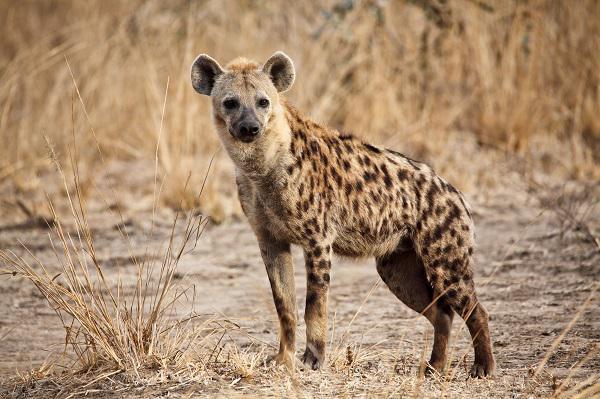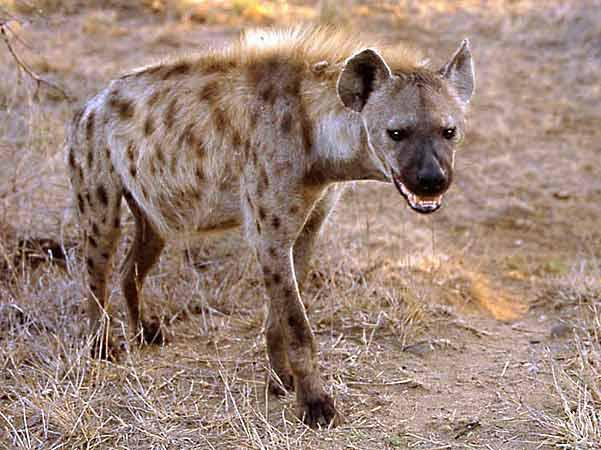The first image is the image on the left, the second image is the image on the right. For the images displayed, is the sentence "There are two hyenas." factually correct? Answer yes or no. Yes. 